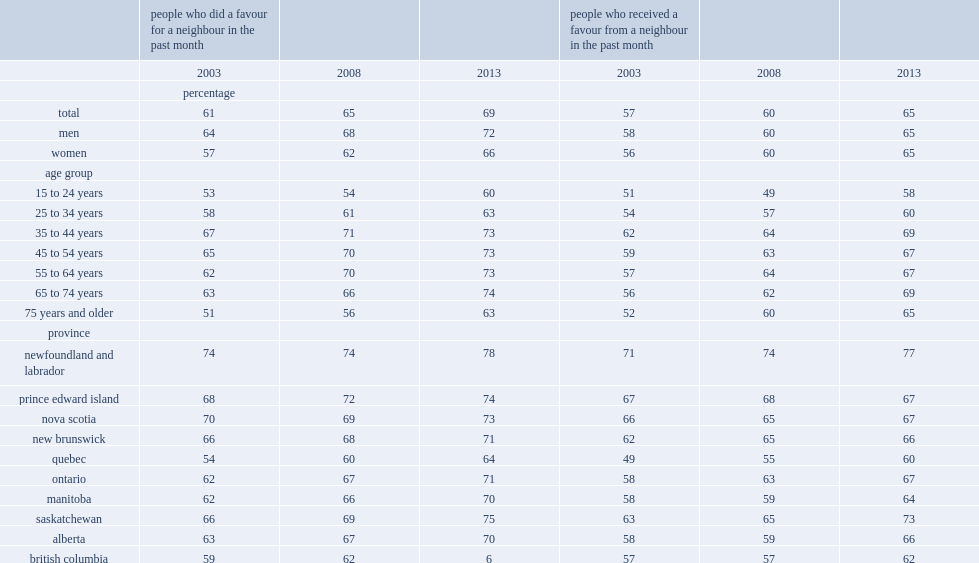What is the percentage of canadians who reported having done a favour for a neighbour in the past month in 2003? 61.0. What is the percentage of canadians who reported having done a favour for a neighbour in the past month in 2013? 69.0. Would you be able to parse every entry in this table? {'header': ['', 'people who did a favour for a neighbour in the past month', '', '', 'people who received a favour from a neighbour in the past month', '', ''], 'rows': [['', '2003', '2008', '2013', '2003', '2008', '2013'], ['', 'percentage', '', '', '', '', ''], ['total', '61', '65', '69', '57', '60', '65'], ['men', '64', '68', '72', '58', '60', '65'], ['women', '57', '62', '66', '56', '60', '65'], ['age group', '', '', '', '', '', ''], ['15 to 24 years', '53', '54', '60', '51', '49', '58'], ['25 to 34 years', '58', '61', '63', '54', '57', '60'], ['35 to 44 years', '67', '71', '73', '62', '64', '69'], ['45 to 54 years', '65', '70', '73', '59', '63', '67'], ['55 to 64 years', '62', '70', '73', '57', '64', '67'], ['65 to 74 years', '63', '66', '74', '56', '62', '69'], ['75 years and older', '51', '56', '63', '52', '60', '65'], ['province', '', '', '', '', '', ''], ['newfoundland and labrador', '74', '74', '78', '71', '74', '77'], ['prince edward island', '68', '72', '74', '67', '68', '67'], ['nova scotia', '70', '69', '73', '66', '65', '67'], ['new brunswick', '66', '68', '71', '62', '65', '66'], ['quebec', '54', '60', '64', '49', '55', '60'], ['ontario', '62', '67', '71', '58', '63', '67'], ['manitoba', '62', '66', '70', '58', '59', '64'], ['saskatchewan', '66', '69', '75', '63', '65', '73'], ['alberta', '63', '67', '70', '58', '59', '66'], ['british columbia', '59', '62', '6', '57', '57', '62']]} 